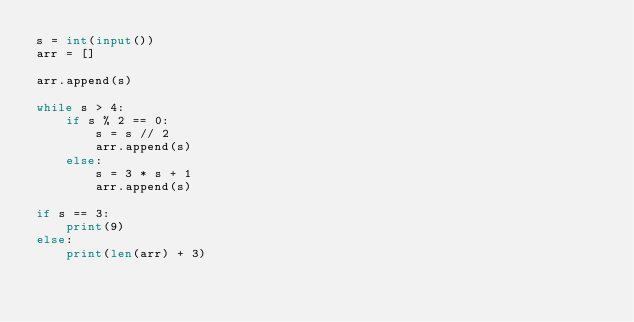<code> <loc_0><loc_0><loc_500><loc_500><_Python_>s = int(input())
arr = []

arr.append(s)

while s > 4:
    if s % 2 == 0:
        s = s // 2
        arr.append(s)
    else:
        s = 3 * s + 1
        arr.append(s)

if s == 3:
    print(9)
else:
    print(len(arr) + 3)</code> 